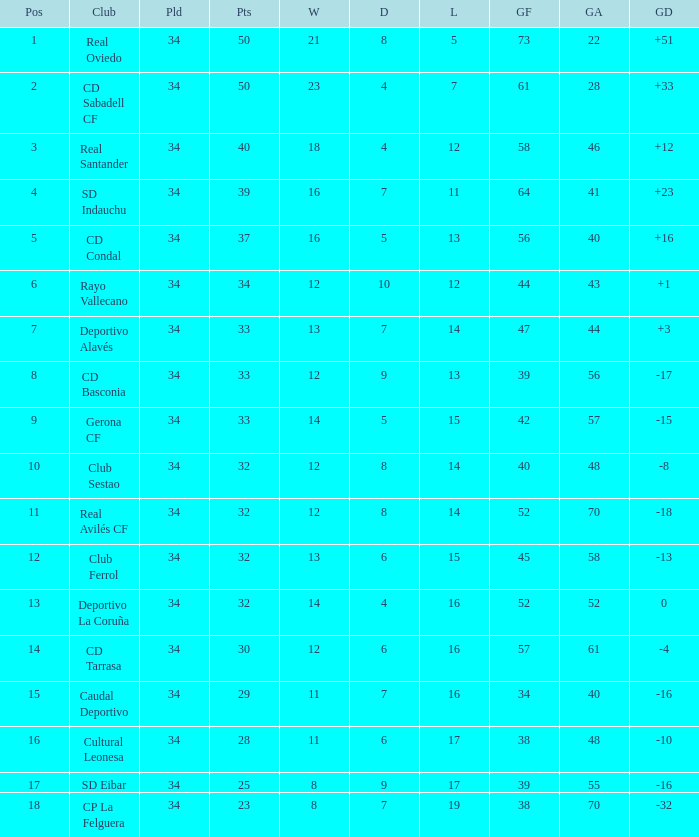Which Losses have a Goal Difference of -16, and less than 8 wins? None. Give me the full table as a dictionary. {'header': ['Pos', 'Club', 'Pld', 'Pts', 'W', 'D', 'L', 'GF', 'GA', 'GD'], 'rows': [['1', 'Real Oviedo', '34', '50', '21', '8', '5', '73', '22', '+51'], ['2', 'CD Sabadell CF', '34', '50', '23', '4', '7', '61', '28', '+33'], ['3', 'Real Santander', '34', '40', '18', '4', '12', '58', '46', '+12'], ['4', 'SD Indauchu', '34', '39', '16', '7', '11', '64', '41', '+23'], ['5', 'CD Condal', '34', '37', '16', '5', '13', '56', '40', '+16'], ['6', 'Rayo Vallecano', '34', '34', '12', '10', '12', '44', '43', '+1'], ['7', 'Deportivo Alavés', '34', '33', '13', '7', '14', '47', '44', '+3'], ['8', 'CD Basconia', '34', '33', '12', '9', '13', '39', '56', '-17'], ['9', 'Gerona CF', '34', '33', '14', '5', '15', '42', '57', '-15'], ['10', 'Club Sestao', '34', '32', '12', '8', '14', '40', '48', '-8'], ['11', 'Real Avilés CF', '34', '32', '12', '8', '14', '52', '70', '-18'], ['12', 'Club Ferrol', '34', '32', '13', '6', '15', '45', '58', '-13'], ['13', 'Deportivo La Coruña', '34', '32', '14', '4', '16', '52', '52', '0'], ['14', 'CD Tarrasa', '34', '30', '12', '6', '16', '57', '61', '-4'], ['15', 'Caudal Deportivo', '34', '29', '11', '7', '16', '34', '40', '-16'], ['16', 'Cultural Leonesa', '34', '28', '11', '6', '17', '38', '48', '-10'], ['17', 'SD Eibar', '34', '25', '8', '9', '17', '39', '55', '-16'], ['18', 'CP La Felguera', '34', '23', '8', '7', '19', '38', '70', '-32']]} 